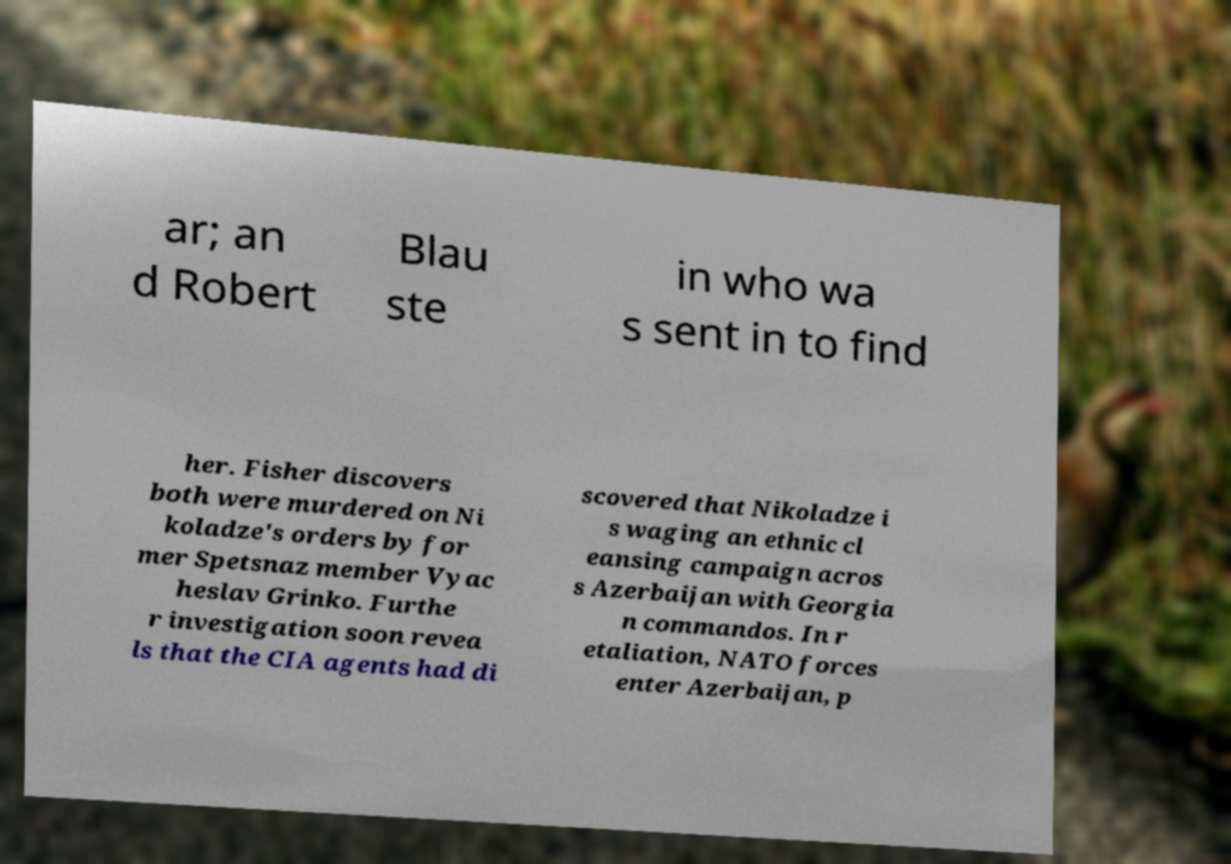Please read and relay the text visible in this image. What does it say? ar; an d Robert Blau ste in who wa s sent in to find her. Fisher discovers both were murdered on Ni koladze's orders by for mer Spetsnaz member Vyac heslav Grinko. Furthe r investigation soon revea ls that the CIA agents had di scovered that Nikoladze i s waging an ethnic cl eansing campaign acros s Azerbaijan with Georgia n commandos. In r etaliation, NATO forces enter Azerbaijan, p 